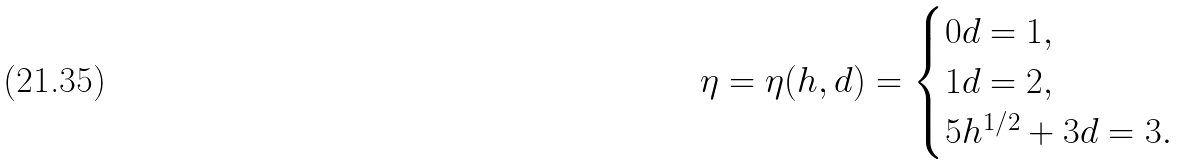Convert formula to latex. <formula><loc_0><loc_0><loc_500><loc_500>\eta = \eta ( h , d ) = \begin{cases} 0 d = 1 , \\ 1 d = 2 , \\ 5 h ^ { 1 / 2 } + 3 d = 3 . \\ \end{cases}</formula> 